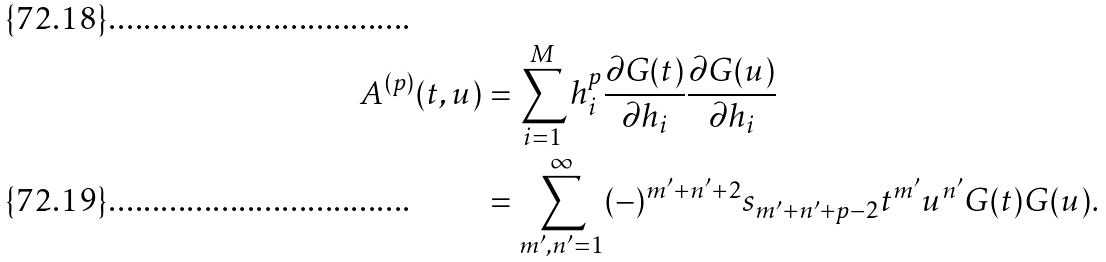Convert formula to latex. <formula><loc_0><loc_0><loc_500><loc_500>A ^ { ( p ) } ( t , u ) & = \sum _ { i = 1 } ^ { M } h _ { i } ^ { p } \frac { \partial G ( t ) } { \partial h _ { i } } \frac { \partial G ( u ) } { \partial h _ { i } } \\ & = \sum _ { m ^ { \prime } , n ^ { \prime } = 1 } ^ { \infty } ( - ) ^ { m ^ { \prime } + n ^ { \prime } + 2 } s _ { m ^ { \prime } + n ^ { \prime } + p - 2 } t ^ { m ^ { \prime } } u ^ { n ^ { \prime } } G ( t ) G ( u ) .</formula> 